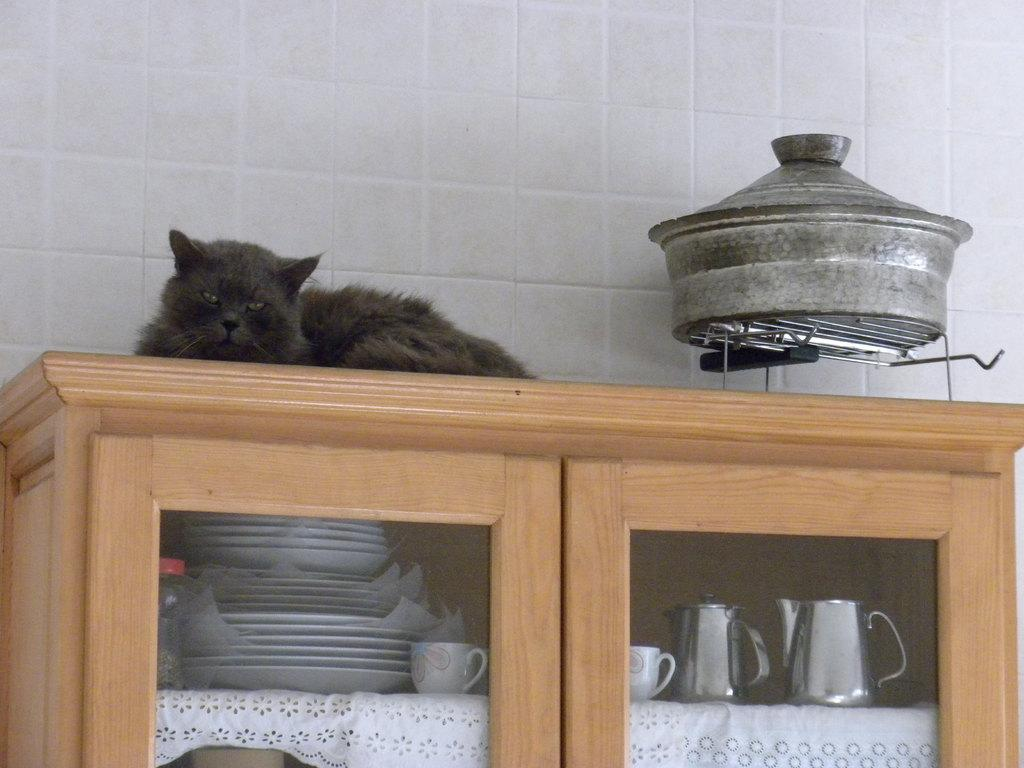What type of furniture is present in the image? There is a cupboard in the image. What is on top of the cupboard? A black color cat is on top of the cupboard. What else is on top of the cupboard besides the cat? There is a container on top of the cupboard. What can be found inside the cupboard? Cups and plates are arranged inside the cupboard. What degree does the cat have in the image? The cat does not have a degree in the image, as cats do not obtain degrees. 